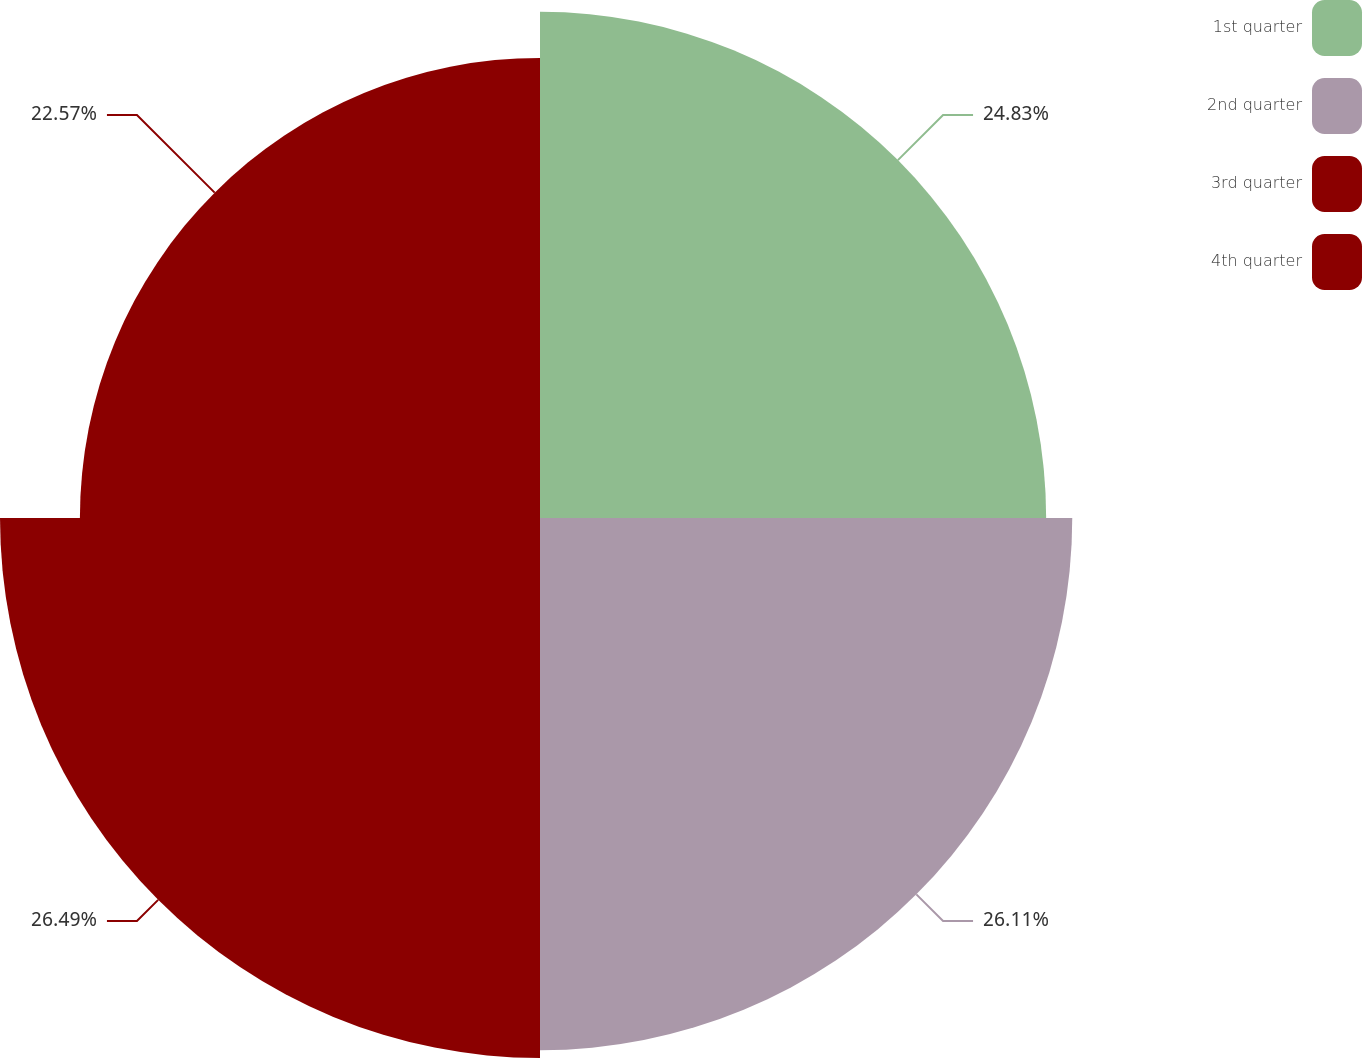<chart> <loc_0><loc_0><loc_500><loc_500><pie_chart><fcel>1st quarter<fcel>2nd quarter<fcel>3rd quarter<fcel>4th quarter<nl><fcel>24.83%<fcel>26.11%<fcel>26.49%<fcel>22.57%<nl></chart> 